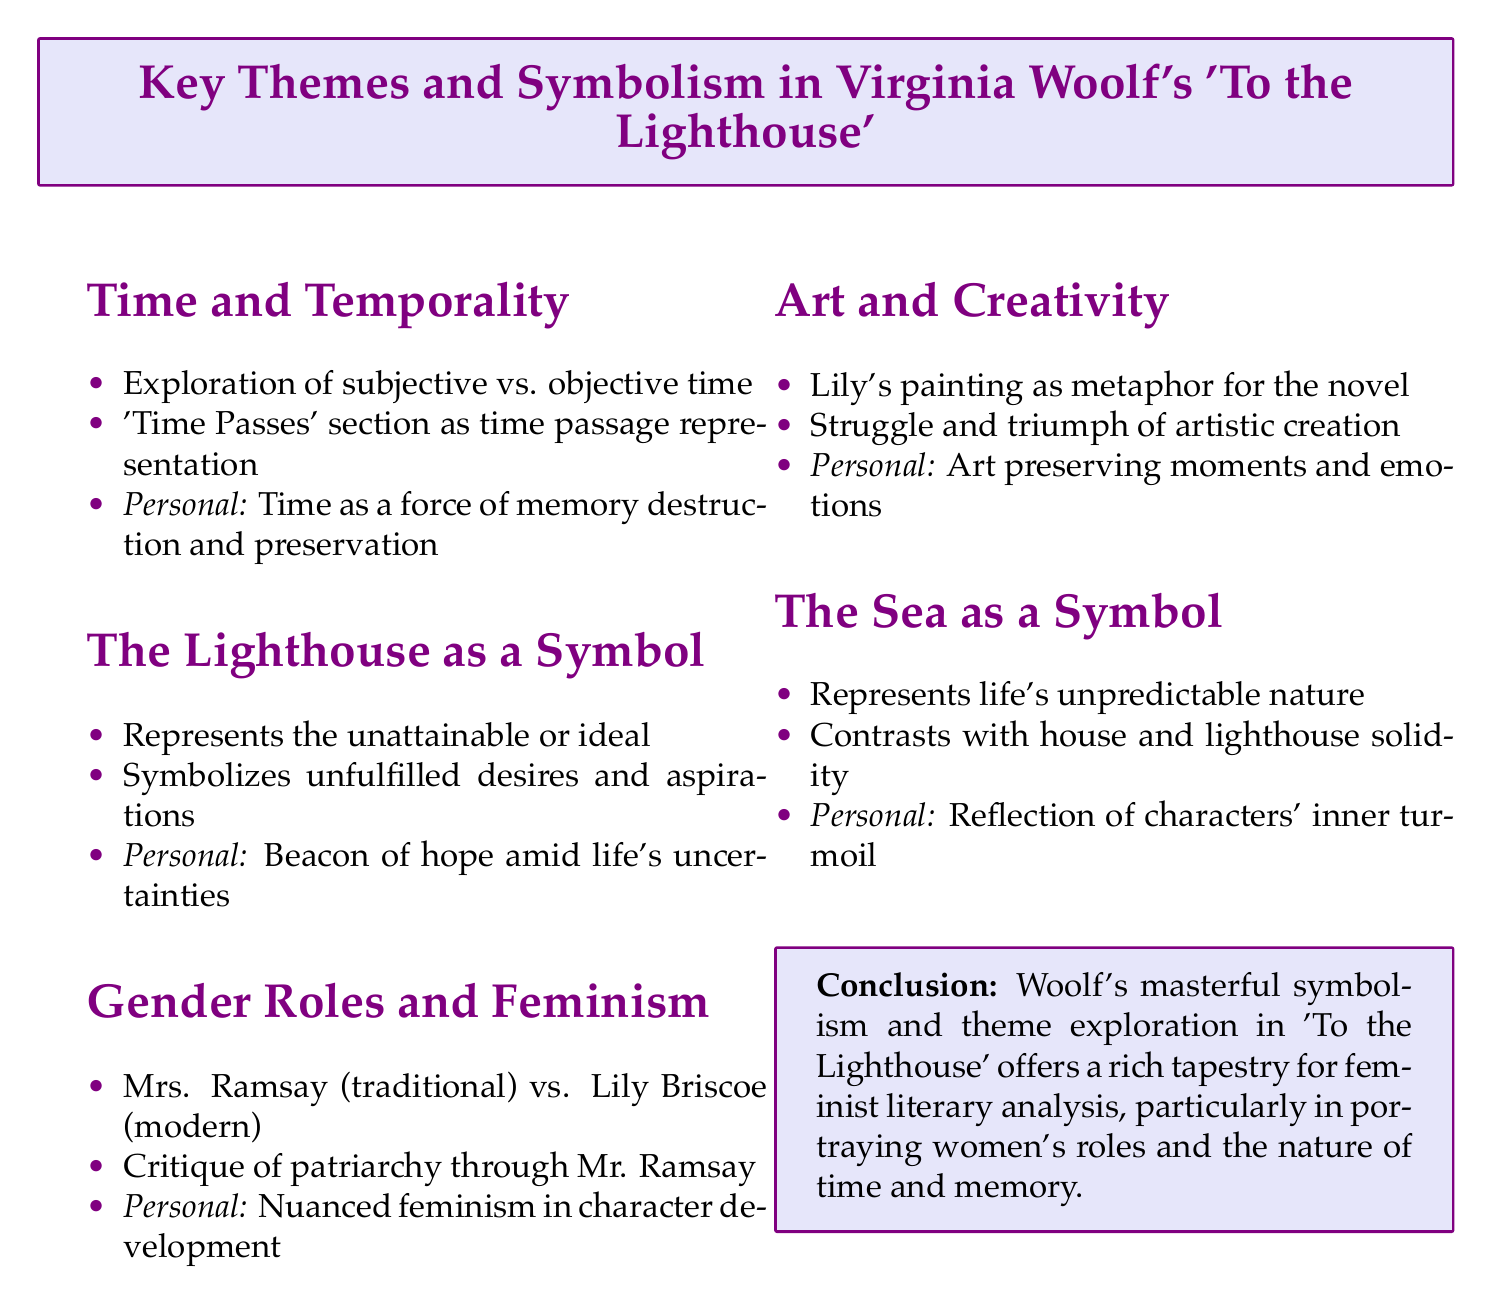What is the title of the document? The title of the document is prominently displayed at the top.
Answer: Key Themes and Symbolism in Virginia Woolf's 'To the Lighthouse' How many sections are there in the document? The number of sections can be counted from the document structure.
Answer: Five What does the lighthouse symbolize according to the notes? This is stated in the section describing the lighthouse's representation.
Answer: The unattainable or the ideal Who are the two characters compared in the section on Gender Roles and Feminism? The characters compared are mentioned in relation to traditional and modern aspects.
Answer: Mrs. Ramsay and Lily Briscoe What personal interpretation is given about time? The specific personal interpretation is noted in the section on Time and Temporality.
Answer: Time as a force that both destroys and preserves memories What artistic metaphor is used in the document? The metaphor related to art in the document describes a character's action.
Answer: Lily's painting as a metaphor for the novel What does the sea represent in Woolf's work? This symbolism is detailed in the section discussing the sea's representation.
Answer: The unpredictable nature of life What critique is mentioned concerning Mr. Ramsay's character? The critique concerning Mr. Ramsay addresses a societal issue.
Answer: Critique of patriarchal society What does Woolf's exploration of themes in 'To the Lighthouse' offer? The conclusion summarizes the overall contribution of Woolf’s work.
Answer: A rich tapestry for feminist literary analysis 